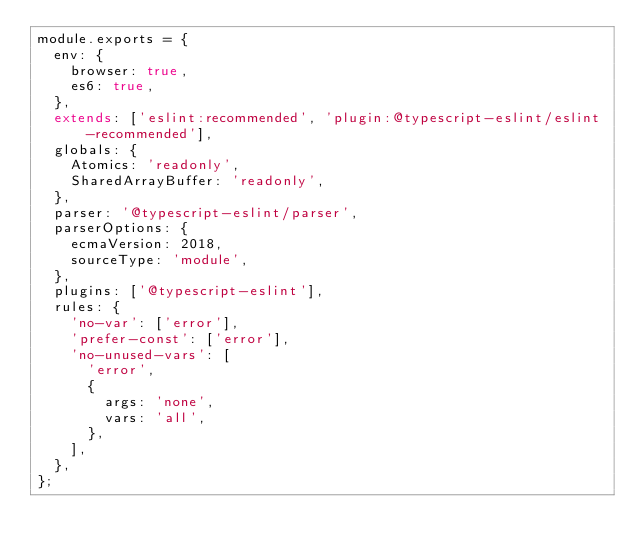Convert code to text. <code><loc_0><loc_0><loc_500><loc_500><_JavaScript_>module.exports = {
  env: {
    browser: true,
    es6: true,
  },
  extends: ['eslint:recommended', 'plugin:@typescript-eslint/eslint-recommended'],
  globals: {
    Atomics: 'readonly',
    SharedArrayBuffer: 'readonly',
  },
  parser: '@typescript-eslint/parser',
  parserOptions: {
    ecmaVersion: 2018,
    sourceType: 'module',
  },
  plugins: ['@typescript-eslint'],
  rules: {
    'no-var': ['error'],
    'prefer-const': ['error'],
    'no-unused-vars': [
      'error',
      {
        args: 'none',
        vars: 'all',
      },
    ],
  },
};
</code> 